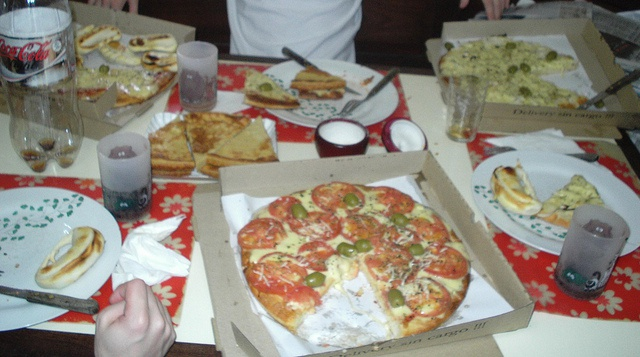Describe the objects in this image and their specific colors. I can see dining table in darkgray, black, gray, tan, and lightgray tones, pizza in black, brown, tan, and beige tones, bottle in black, gray, darkgray, and darkgreen tones, people in black, darkgray, and gray tones, and pizza in black, olive, and darkgreen tones in this image. 